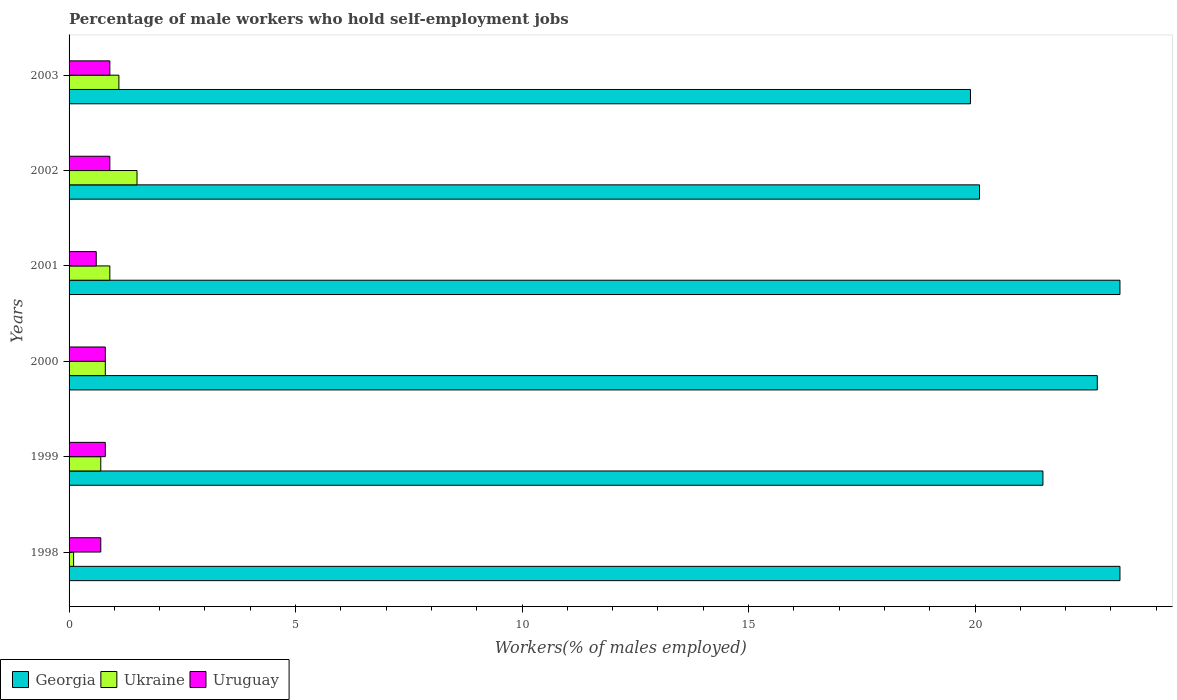How many groups of bars are there?
Ensure brevity in your answer.  6. How many bars are there on the 4th tick from the top?
Make the answer very short. 3. What is the percentage of self-employed male workers in Ukraine in 2001?
Ensure brevity in your answer.  0.9. Across all years, what is the maximum percentage of self-employed male workers in Georgia?
Provide a short and direct response. 23.2. Across all years, what is the minimum percentage of self-employed male workers in Georgia?
Your answer should be very brief. 19.9. In which year was the percentage of self-employed male workers in Ukraine maximum?
Give a very brief answer. 2002. In which year was the percentage of self-employed male workers in Ukraine minimum?
Provide a short and direct response. 1998. What is the total percentage of self-employed male workers in Georgia in the graph?
Your response must be concise. 130.6. What is the difference between the percentage of self-employed male workers in Georgia in 1999 and that in 2002?
Make the answer very short. 1.4. What is the difference between the percentage of self-employed male workers in Ukraine in 2000 and the percentage of self-employed male workers in Georgia in 1999?
Offer a terse response. -20.7. What is the average percentage of self-employed male workers in Georgia per year?
Offer a terse response. 21.77. In the year 2002, what is the difference between the percentage of self-employed male workers in Uruguay and percentage of self-employed male workers in Georgia?
Your answer should be compact. -19.2. What is the ratio of the percentage of self-employed male workers in Uruguay in 1999 to that in 2000?
Your answer should be compact. 1. Is the percentage of self-employed male workers in Georgia in 2001 less than that in 2002?
Your answer should be compact. No. What is the difference between the highest and the lowest percentage of self-employed male workers in Uruguay?
Offer a very short reply. 0.3. Is the sum of the percentage of self-employed male workers in Georgia in 2001 and 2003 greater than the maximum percentage of self-employed male workers in Uruguay across all years?
Offer a very short reply. Yes. What does the 2nd bar from the top in 2001 represents?
Your response must be concise. Ukraine. What does the 3rd bar from the bottom in 1999 represents?
Offer a very short reply. Uruguay. How many bars are there?
Provide a short and direct response. 18. Are all the bars in the graph horizontal?
Your response must be concise. Yes. How many years are there in the graph?
Offer a terse response. 6. What is the difference between two consecutive major ticks on the X-axis?
Give a very brief answer. 5. Are the values on the major ticks of X-axis written in scientific E-notation?
Your answer should be very brief. No. Does the graph contain any zero values?
Keep it short and to the point. No. How are the legend labels stacked?
Provide a short and direct response. Horizontal. What is the title of the graph?
Your response must be concise. Percentage of male workers who hold self-employment jobs. Does "Cambodia" appear as one of the legend labels in the graph?
Your response must be concise. No. What is the label or title of the X-axis?
Keep it short and to the point. Workers(% of males employed). What is the Workers(% of males employed) of Georgia in 1998?
Your answer should be very brief. 23.2. What is the Workers(% of males employed) of Ukraine in 1998?
Make the answer very short. 0.1. What is the Workers(% of males employed) of Uruguay in 1998?
Provide a short and direct response. 0.7. What is the Workers(% of males employed) of Georgia in 1999?
Ensure brevity in your answer.  21.5. What is the Workers(% of males employed) of Ukraine in 1999?
Your answer should be very brief. 0.7. What is the Workers(% of males employed) in Uruguay in 1999?
Provide a short and direct response. 0.8. What is the Workers(% of males employed) of Georgia in 2000?
Offer a terse response. 22.7. What is the Workers(% of males employed) of Ukraine in 2000?
Your answer should be compact. 0.8. What is the Workers(% of males employed) in Uruguay in 2000?
Your answer should be very brief. 0.8. What is the Workers(% of males employed) of Georgia in 2001?
Give a very brief answer. 23.2. What is the Workers(% of males employed) of Ukraine in 2001?
Ensure brevity in your answer.  0.9. What is the Workers(% of males employed) in Uruguay in 2001?
Offer a very short reply. 0.6. What is the Workers(% of males employed) in Georgia in 2002?
Keep it short and to the point. 20.1. What is the Workers(% of males employed) in Uruguay in 2002?
Provide a short and direct response. 0.9. What is the Workers(% of males employed) of Georgia in 2003?
Your response must be concise. 19.9. What is the Workers(% of males employed) of Ukraine in 2003?
Ensure brevity in your answer.  1.1. What is the Workers(% of males employed) in Uruguay in 2003?
Provide a succinct answer. 0.9. Across all years, what is the maximum Workers(% of males employed) in Georgia?
Provide a short and direct response. 23.2. Across all years, what is the maximum Workers(% of males employed) of Ukraine?
Ensure brevity in your answer.  1.5. Across all years, what is the maximum Workers(% of males employed) of Uruguay?
Your response must be concise. 0.9. Across all years, what is the minimum Workers(% of males employed) in Georgia?
Your response must be concise. 19.9. Across all years, what is the minimum Workers(% of males employed) of Ukraine?
Provide a succinct answer. 0.1. Across all years, what is the minimum Workers(% of males employed) of Uruguay?
Give a very brief answer. 0.6. What is the total Workers(% of males employed) of Georgia in the graph?
Provide a succinct answer. 130.6. What is the total Workers(% of males employed) of Uruguay in the graph?
Provide a short and direct response. 4.7. What is the difference between the Workers(% of males employed) of Georgia in 1998 and that in 1999?
Provide a succinct answer. 1.7. What is the difference between the Workers(% of males employed) of Ukraine in 1998 and that in 1999?
Make the answer very short. -0.6. What is the difference between the Workers(% of males employed) in Uruguay in 1998 and that in 1999?
Your answer should be compact. -0.1. What is the difference between the Workers(% of males employed) in Georgia in 1998 and that in 2000?
Your answer should be compact. 0.5. What is the difference between the Workers(% of males employed) of Ukraine in 1998 and that in 2000?
Provide a succinct answer. -0.7. What is the difference between the Workers(% of males employed) in Uruguay in 1998 and that in 2000?
Provide a short and direct response. -0.1. What is the difference between the Workers(% of males employed) in Georgia in 1998 and that in 2002?
Provide a short and direct response. 3.1. What is the difference between the Workers(% of males employed) in Ukraine in 1998 and that in 2003?
Your answer should be compact. -1. What is the difference between the Workers(% of males employed) of Georgia in 1999 and that in 2000?
Give a very brief answer. -1.2. What is the difference between the Workers(% of males employed) in Ukraine in 1999 and that in 2000?
Provide a succinct answer. -0.1. What is the difference between the Workers(% of males employed) in Uruguay in 1999 and that in 2000?
Ensure brevity in your answer.  0. What is the difference between the Workers(% of males employed) of Georgia in 1999 and that in 2001?
Your response must be concise. -1.7. What is the difference between the Workers(% of males employed) in Ukraine in 1999 and that in 2001?
Your response must be concise. -0.2. What is the difference between the Workers(% of males employed) of Georgia in 1999 and that in 2002?
Provide a short and direct response. 1.4. What is the difference between the Workers(% of males employed) of Ukraine in 1999 and that in 2002?
Provide a succinct answer. -0.8. What is the difference between the Workers(% of males employed) of Georgia in 1999 and that in 2003?
Provide a short and direct response. 1.6. What is the difference between the Workers(% of males employed) of Ukraine in 2000 and that in 2001?
Your answer should be very brief. -0.1. What is the difference between the Workers(% of males employed) in Georgia in 2000 and that in 2002?
Make the answer very short. 2.6. What is the difference between the Workers(% of males employed) in Uruguay in 2000 and that in 2003?
Make the answer very short. -0.1. What is the difference between the Workers(% of males employed) of Georgia in 2001 and that in 2002?
Your response must be concise. 3.1. What is the difference between the Workers(% of males employed) in Georgia in 2001 and that in 2003?
Give a very brief answer. 3.3. What is the difference between the Workers(% of males employed) in Georgia in 2002 and that in 2003?
Provide a short and direct response. 0.2. What is the difference between the Workers(% of males employed) in Uruguay in 2002 and that in 2003?
Give a very brief answer. 0. What is the difference between the Workers(% of males employed) in Georgia in 1998 and the Workers(% of males employed) in Uruguay in 1999?
Provide a succinct answer. 22.4. What is the difference between the Workers(% of males employed) of Georgia in 1998 and the Workers(% of males employed) of Ukraine in 2000?
Your answer should be very brief. 22.4. What is the difference between the Workers(% of males employed) in Georgia in 1998 and the Workers(% of males employed) in Uruguay in 2000?
Ensure brevity in your answer.  22.4. What is the difference between the Workers(% of males employed) of Ukraine in 1998 and the Workers(% of males employed) of Uruguay in 2000?
Make the answer very short. -0.7. What is the difference between the Workers(% of males employed) in Georgia in 1998 and the Workers(% of males employed) in Ukraine in 2001?
Ensure brevity in your answer.  22.3. What is the difference between the Workers(% of males employed) in Georgia in 1998 and the Workers(% of males employed) in Uruguay in 2001?
Provide a short and direct response. 22.6. What is the difference between the Workers(% of males employed) in Ukraine in 1998 and the Workers(% of males employed) in Uruguay in 2001?
Keep it short and to the point. -0.5. What is the difference between the Workers(% of males employed) of Georgia in 1998 and the Workers(% of males employed) of Ukraine in 2002?
Give a very brief answer. 21.7. What is the difference between the Workers(% of males employed) of Georgia in 1998 and the Workers(% of males employed) of Uruguay in 2002?
Provide a short and direct response. 22.3. What is the difference between the Workers(% of males employed) of Ukraine in 1998 and the Workers(% of males employed) of Uruguay in 2002?
Make the answer very short. -0.8. What is the difference between the Workers(% of males employed) of Georgia in 1998 and the Workers(% of males employed) of Ukraine in 2003?
Give a very brief answer. 22.1. What is the difference between the Workers(% of males employed) of Georgia in 1998 and the Workers(% of males employed) of Uruguay in 2003?
Ensure brevity in your answer.  22.3. What is the difference between the Workers(% of males employed) in Ukraine in 1998 and the Workers(% of males employed) in Uruguay in 2003?
Offer a terse response. -0.8. What is the difference between the Workers(% of males employed) in Georgia in 1999 and the Workers(% of males employed) in Ukraine in 2000?
Ensure brevity in your answer.  20.7. What is the difference between the Workers(% of males employed) of Georgia in 1999 and the Workers(% of males employed) of Uruguay in 2000?
Provide a short and direct response. 20.7. What is the difference between the Workers(% of males employed) of Georgia in 1999 and the Workers(% of males employed) of Ukraine in 2001?
Offer a very short reply. 20.6. What is the difference between the Workers(% of males employed) in Georgia in 1999 and the Workers(% of males employed) in Uruguay in 2001?
Provide a succinct answer. 20.9. What is the difference between the Workers(% of males employed) of Georgia in 1999 and the Workers(% of males employed) of Ukraine in 2002?
Ensure brevity in your answer.  20. What is the difference between the Workers(% of males employed) in Georgia in 1999 and the Workers(% of males employed) in Uruguay in 2002?
Make the answer very short. 20.6. What is the difference between the Workers(% of males employed) of Ukraine in 1999 and the Workers(% of males employed) of Uruguay in 2002?
Provide a short and direct response. -0.2. What is the difference between the Workers(% of males employed) in Georgia in 1999 and the Workers(% of males employed) in Ukraine in 2003?
Your response must be concise. 20.4. What is the difference between the Workers(% of males employed) of Georgia in 1999 and the Workers(% of males employed) of Uruguay in 2003?
Keep it short and to the point. 20.6. What is the difference between the Workers(% of males employed) in Georgia in 2000 and the Workers(% of males employed) in Ukraine in 2001?
Your response must be concise. 21.8. What is the difference between the Workers(% of males employed) in Georgia in 2000 and the Workers(% of males employed) in Uruguay in 2001?
Offer a terse response. 22.1. What is the difference between the Workers(% of males employed) in Ukraine in 2000 and the Workers(% of males employed) in Uruguay in 2001?
Keep it short and to the point. 0.2. What is the difference between the Workers(% of males employed) in Georgia in 2000 and the Workers(% of males employed) in Ukraine in 2002?
Offer a terse response. 21.2. What is the difference between the Workers(% of males employed) in Georgia in 2000 and the Workers(% of males employed) in Uruguay in 2002?
Ensure brevity in your answer.  21.8. What is the difference between the Workers(% of males employed) in Georgia in 2000 and the Workers(% of males employed) in Ukraine in 2003?
Make the answer very short. 21.6. What is the difference between the Workers(% of males employed) in Georgia in 2000 and the Workers(% of males employed) in Uruguay in 2003?
Offer a terse response. 21.8. What is the difference between the Workers(% of males employed) in Ukraine in 2000 and the Workers(% of males employed) in Uruguay in 2003?
Provide a succinct answer. -0.1. What is the difference between the Workers(% of males employed) in Georgia in 2001 and the Workers(% of males employed) in Ukraine in 2002?
Your answer should be very brief. 21.7. What is the difference between the Workers(% of males employed) in Georgia in 2001 and the Workers(% of males employed) in Uruguay in 2002?
Give a very brief answer. 22.3. What is the difference between the Workers(% of males employed) in Ukraine in 2001 and the Workers(% of males employed) in Uruguay in 2002?
Ensure brevity in your answer.  0. What is the difference between the Workers(% of males employed) of Georgia in 2001 and the Workers(% of males employed) of Ukraine in 2003?
Give a very brief answer. 22.1. What is the difference between the Workers(% of males employed) of Georgia in 2001 and the Workers(% of males employed) of Uruguay in 2003?
Ensure brevity in your answer.  22.3. What is the difference between the Workers(% of males employed) of Georgia in 2002 and the Workers(% of males employed) of Ukraine in 2003?
Provide a succinct answer. 19. What is the average Workers(% of males employed) in Georgia per year?
Provide a short and direct response. 21.77. What is the average Workers(% of males employed) of Uruguay per year?
Give a very brief answer. 0.78. In the year 1998, what is the difference between the Workers(% of males employed) in Georgia and Workers(% of males employed) in Ukraine?
Keep it short and to the point. 23.1. In the year 1998, what is the difference between the Workers(% of males employed) in Georgia and Workers(% of males employed) in Uruguay?
Your answer should be compact. 22.5. In the year 1999, what is the difference between the Workers(% of males employed) in Georgia and Workers(% of males employed) in Ukraine?
Ensure brevity in your answer.  20.8. In the year 1999, what is the difference between the Workers(% of males employed) in Georgia and Workers(% of males employed) in Uruguay?
Give a very brief answer. 20.7. In the year 2000, what is the difference between the Workers(% of males employed) of Georgia and Workers(% of males employed) of Ukraine?
Make the answer very short. 21.9. In the year 2000, what is the difference between the Workers(% of males employed) in Georgia and Workers(% of males employed) in Uruguay?
Your response must be concise. 21.9. In the year 2001, what is the difference between the Workers(% of males employed) in Georgia and Workers(% of males employed) in Ukraine?
Your answer should be compact. 22.3. In the year 2001, what is the difference between the Workers(% of males employed) of Georgia and Workers(% of males employed) of Uruguay?
Your response must be concise. 22.6. In the year 2003, what is the difference between the Workers(% of males employed) in Georgia and Workers(% of males employed) in Ukraine?
Keep it short and to the point. 18.8. In the year 2003, what is the difference between the Workers(% of males employed) in Georgia and Workers(% of males employed) in Uruguay?
Your answer should be very brief. 19. What is the ratio of the Workers(% of males employed) of Georgia in 1998 to that in 1999?
Ensure brevity in your answer.  1.08. What is the ratio of the Workers(% of males employed) in Ukraine in 1998 to that in 1999?
Your answer should be very brief. 0.14. What is the ratio of the Workers(% of males employed) of Georgia in 1998 to that in 2000?
Your response must be concise. 1.02. What is the ratio of the Workers(% of males employed) in Uruguay in 1998 to that in 2000?
Offer a very short reply. 0.88. What is the ratio of the Workers(% of males employed) of Ukraine in 1998 to that in 2001?
Keep it short and to the point. 0.11. What is the ratio of the Workers(% of males employed) of Uruguay in 1998 to that in 2001?
Your answer should be compact. 1.17. What is the ratio of the Workers(% of males employed) in Georgia in 1998 to that in 2002?
Give a very brief answer. 1.15. What is the ratio of the Workers(% of males employed) in Ukraine in 1998 to that in 2002?
Provide a succinct answer. 0.07. What is the ratio of the Workers(% of males employed) in Uruguay in 1998 to that in 2002?
Your response must be concise. 0.78. What is the ratio of the Workers(% of males employed) in Georgia in 1998 to that in 2003?
Offer a terse response. 1.17. What is the ratio of the Workers(% of males employed) of Ukraine in 1998 to that in 2003?
Your answer should be compact. 0.09. What is the ratio of the Workers(% of males employed) in Georgia in 1999 to that in 2000?
Make the answer very short. 0.95. What is the ratio of the Workers(% of males employed) in Uruguay in 1999 to that in 2000?
Your answer should be compact. 1. What is the ratio of the Workers(% of males employed) in Georgia in 1999 to that in 2001?
Keep it short and to the point. 0.93. What is the ratio of the Workers(% of males employed) in Ukraine in 1999 to that in 2001?
Provide a succinct answer. 0.78. What is the ratio of the Workers(% of males employed) of Georgia in 1999 to that in 2002?
Your response must be concise. 1.07. What is the ratio of the Workers(% of males employed) of Ukraine in 1999 to that in 2002?
Offer a terse response. 0.47. What is the ratio of the Workers(% of males employed) of Georgia in 1999 to that in 2003?
Your response must be concise. 1.08. What is the ratio of the Workers(% of males employed) of Ukraine in 1999 to that in 2003?
Provide a short and direct response. 0.64. What is the ratio of the Workers(% of males employed) in Uruguay in 1999 to that in 2003?
Your answer should be compact. 0.89. What is the ratio of the Workers(% of males employed) in Georgia in 2000 to that in 2001?
Your answer should be very brief. 0.98. What is the ratio of the Workers(% of males employed) of Uruguay in 2000 to that in 2001?
Offer a terse response. 1.33. What is the ratio of the Workers(% of males employed) in Georgia in 2000 to that in 2002?
Ensure brevity in your answer.  1.13. What is the ratio of the Workers(% of males employed) in Ukraine in 2000 to that in 2002?
Your answer should be very brief. 0.53. What is the ratio of the Workers(% of males employed) in Uruguay in 2000 to that in 2002?
Ensure brevity in your answer.  0.89. What is the ratio of the Workers(% of males employed) in Georgia in 2000 to that in 2003?
Provide a short and direct response. 1.14. What is the ratio of the Workers(% of males employed) of Ukraine in 2000 to that in 2003?
Keep it short and to the point. 0.73. What is the ratio of the Workers(% of males employed) of Uruguay in 2000 to that in 2003?
Ensure brevity in your answer.  0.89. What is the ratio of the Workers(% of males employed) in Georgia in 2001 to that in 2002?
Give a very brief answer. 1.15. What is the ratio of the Workers(% of males employed) of Georgia in 2001 to that in 2003?
Your answer should be very brief. 1.17. What is the ratio of the Workers(% of males employed) in Ukraine in 2001 to that in 2003?
Provide a succinct answer. 0.82. What is the ratio of the Workers(% of males employed) in Georgia in 2002 to that in 2003?
Ensure brevity in your answer.  1.01. What is the ratio of the Workers(% of males employed) of Ukraine in 2002 to that in 2003?
Ensure brevity in your answer.  1.36. What is the difference between the highest and the second highest Workers(% of males employed) of Ukraine?
Offer a very short reply. 0.4. What is the difference between the highest and the lowest Workers(% of males employed) in Ukraine?
Offer a very short reply. 1.4. 